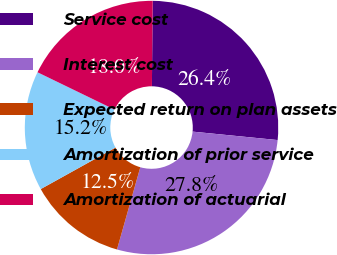<chart> <loc_0><loc_0><loc_500><loc_500><pie_chart><fcel>Service cost<fcel>Interest cost<fcel>Expected return on plan assets<fcel>Amortization of prior service<fcel>Amortization of actuarial<nl><fcel>26.43%<fcel>27.82%<fcel>12.54%<fcel>15.25%<fcel>17.96%<nl></chart> 